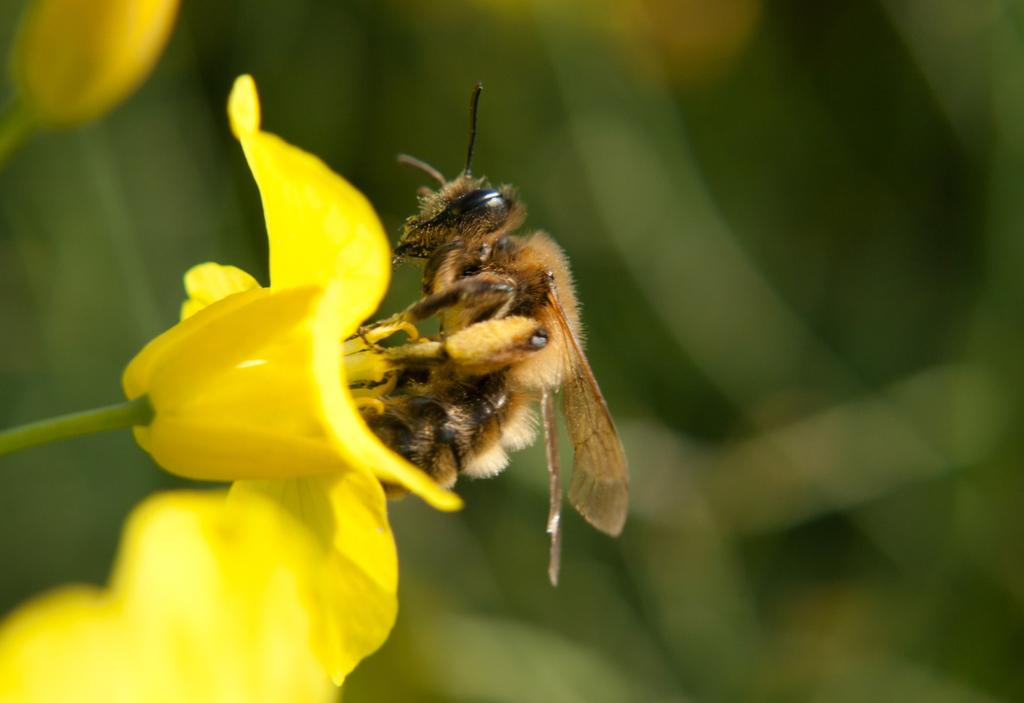What is present in the image? There is an insect in the image. Where is the insect located? The insect is on a flower. Can you describe the background of the image? The background of the image is blurred. What type of rifle can be seen in the image? There is no rifle present in the image; it features an insect on a flower with a blurred background. 